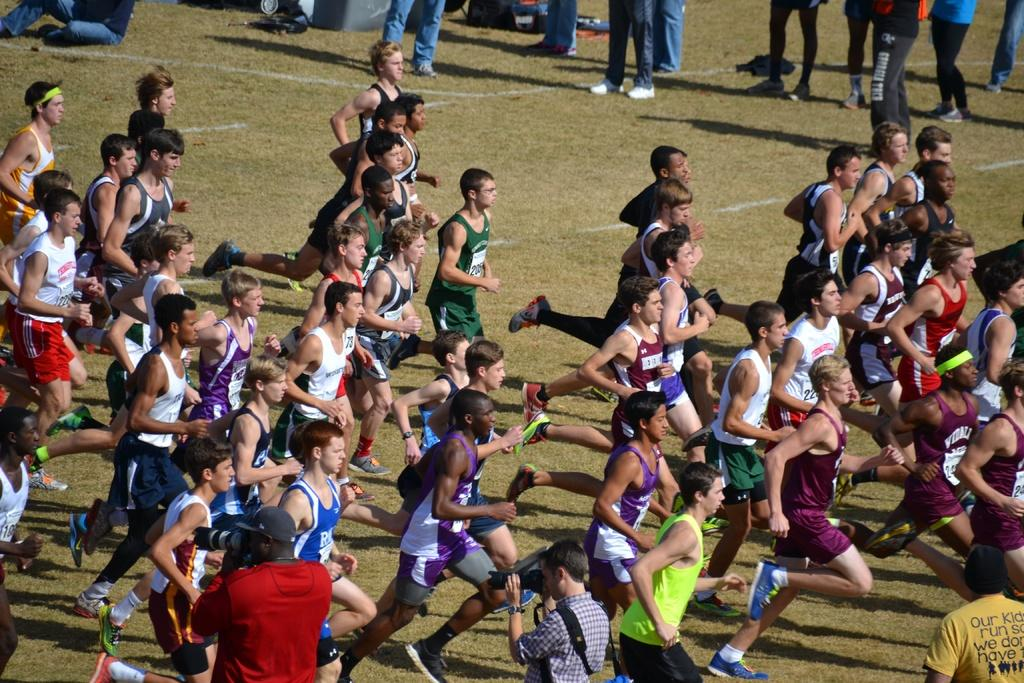What can be seen in the image? There are men in the image. What are the men wearing? The men are wearing t-shirts and shirts. What are the men doing in the image? The men are running in the ground. In which direction are the men running? The men are running towards the right side. What else can be seen in the image? There are people standing at the top of the image. What type of letter is being delivered by the geese in the image? There are no geese or letters present in the image. What kind of battle is taking place in the image? There is no battle depicted in the image; the men are simply running. 